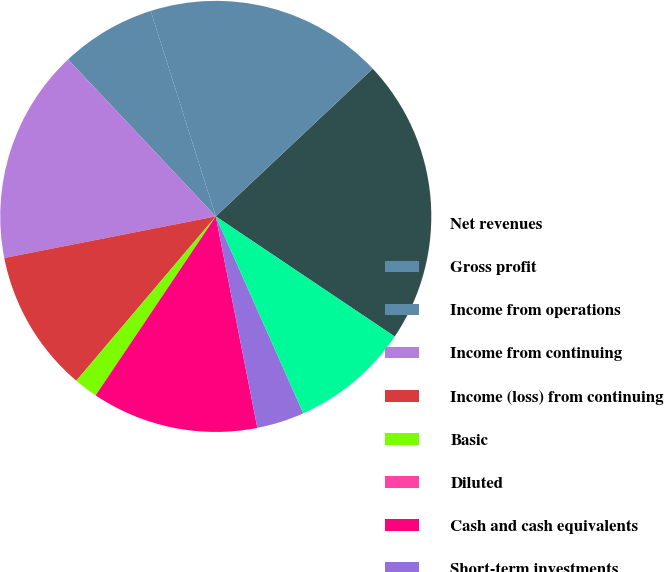<chart> <loc_0><loc_0><loc_500><loc_500><pie_chart><fcel>Net revenues<fcel>Gross profit<fcel>Income from operations<fcel>Income from continuing<fcel>Income (loss) from continuing<fcel>Basic<fcel>Diluted<fcel>Cash and cash equivalents<fcel>Short-term investments<fcel>Long-term investments<nl><fcel>21.43%<fcel>17.86%<fcel>7.14%<fcel>16.07%<fcel>10.71%<fcel>1.79%<fcel>0.0%<fcel>12.5%<fcel>3.57%<fcel>8.93%<nl></chart> 